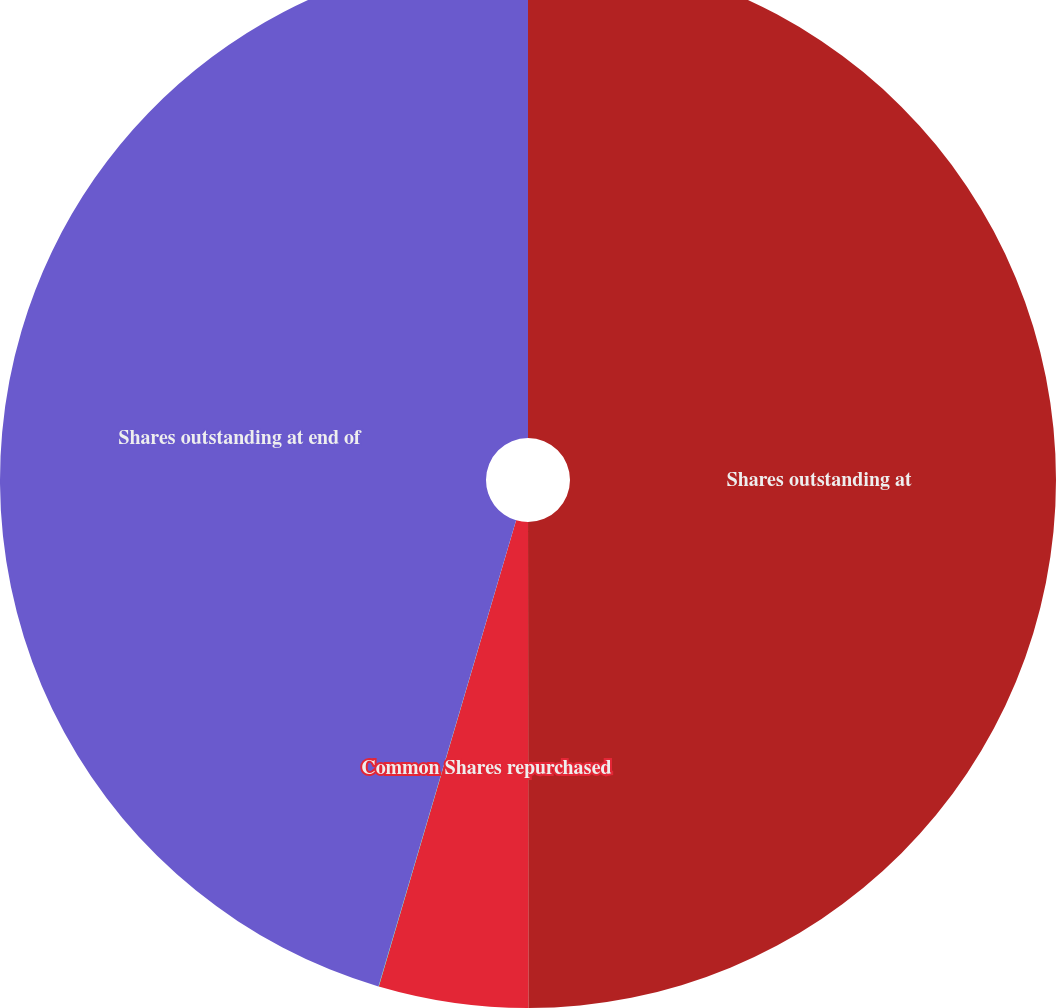Convert chart to OTSL. <chart><loc_0><loc_0><loc_500><loc_500><pie_chart><fcel>Shares outstanding at<fcel>Common Shares repurchased<fcel>Shares reissued (returned)<fcel>Shares outstanding at end of<nl><fcel>49.99%<fcel>4.57%<fcel>0.01%<fcel>45.43%<nl></chart> 